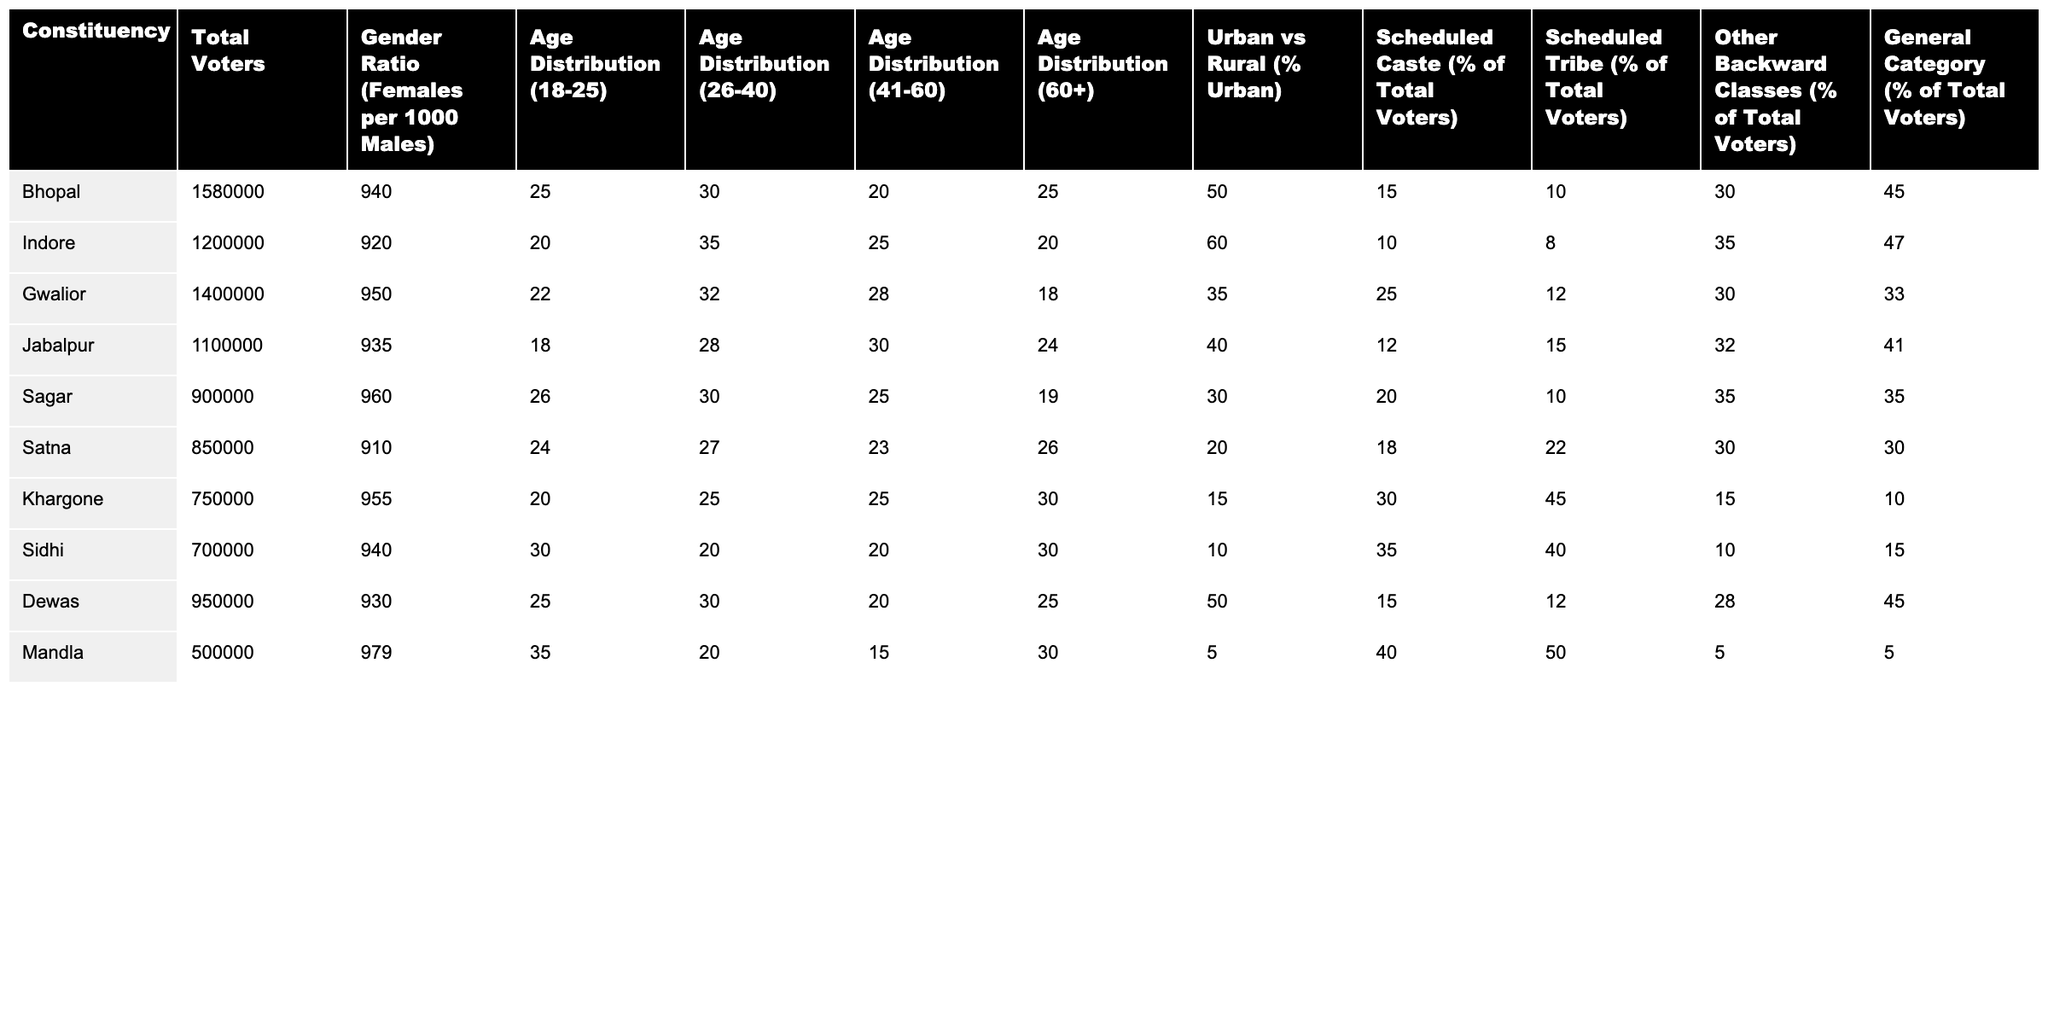What is the gender ratio in the Bhopal constituency? The gender ratio in Bhopal is given directly in the table as 940 females per 1000 males.
Answer: 940 Which constituency has the highest number of total voters? By checking the "Total Voters" column, the constituency with the highest number of total voters is Bhopal with 1,580,000 voters.
Answer: Bhopal What percentage of voters in Indore belong to Scheduled Tribes? For Indore, the percentage of voters from Scheduled Tribes is listed as 8%.
Answer: 8% Calculate the average age distribution (41-60) across all constituencies. The age distribution for 41-60 across constituencies is: Bhopal 20, Indore 25, Gwalior 28, Jabalpur 30, Sagar 25, Satna 23, Khargone 25, Sidhi 20, Dewas 20, and Mandla 15. Summing these values gives 20 + 25 + 28 + 30 + 25 + 23 + 25 + 20 + 20 + 15 =  243. There are 10 constituencies, so the average is 243 / 10 = 24.3.
Answer: 24.3 Is the percentage of Scheduled Caste voters in Sagar higher than that in Jabalpur? In Sagar, the percentage of Scheduled Caste voters is 20%, while in Jabalpur it is 12%. Since 20% is greater than 12%, the statement is true.
Answer: Yes Which constituency shows the largest urban voter percentage? The table indicates that Indore has the highest urban voter percentage at 60%.
Answer: Indore What is the difference in the percentage of Scheduled Caste voters between Gwalior and Dewas? Gwalior has 25% Scheduled Caste voters while Dewas has 15%. The difference is 25% - 15% = 10%.
Answer: 10% Which constituency has the lowest percentage of voters from Other Backward Classes (OBC)? By comparing the percentages of OBC voters, Mandla has the lowest percentage at 5%.
Answer: Mandla How many total voters are there in Madhya Pradesh across all listed constituencies? Summing the total voters across all constituencies gives: 1580000 + 1200000 + 1400000 + 1100000 + 900000 + 850000 + 750000 + 700000 + 950000 + 500000 = 10000000.
Answer: 10,000,000 Is the urban voter percentage in Satna greater than that in Sidhi? Satna has 20% urban voters while Sidhi has 10%. Since 20% is greater than 10%, the statement is true.
Answer: Yes Which age group has the highest distribution overall? Reviewing the age distribution across constituencies reveals that the age group 26-40 has the highest percentages when summing: Bhopal (30) + Indore (35) + Gwalior (32) + Jabalpur (28) + Sagar (30) + Satna (27) + Khargone (25) + Sidhi (20) + Dewas (30) + Mandla (20) =  30 + 35 + 32 + 28 + 30 + 27 + 25 + 20 + 30 + 20 =  307, with an average of 30.7.
Answer: 30.7 